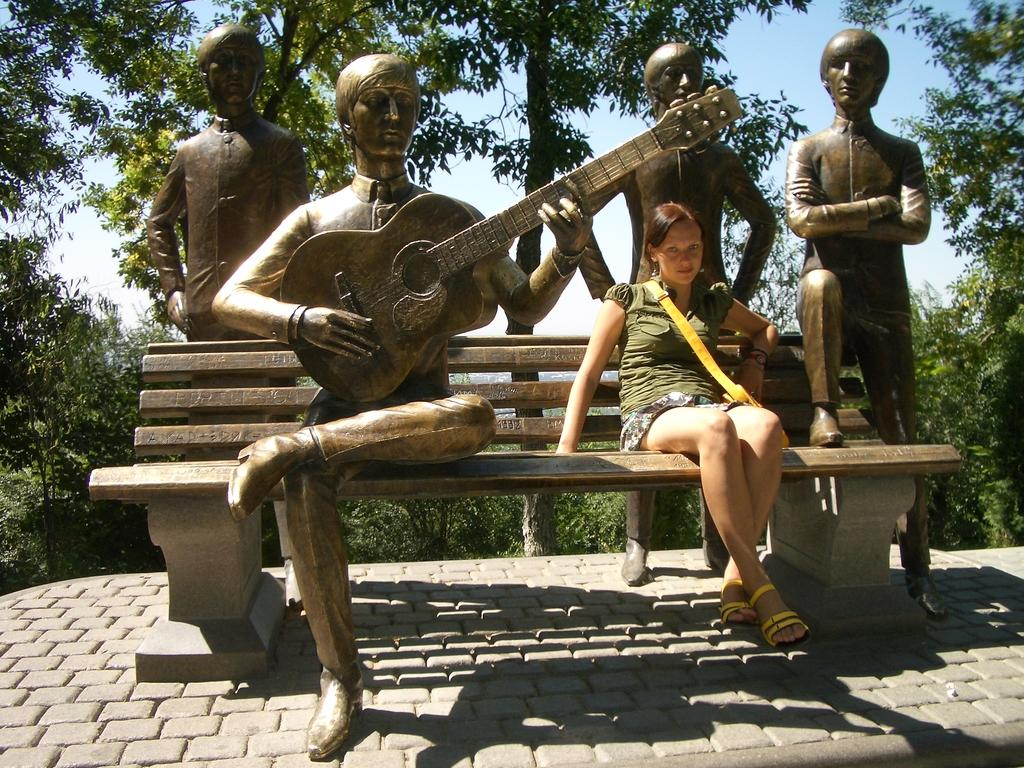What type of natural elements can be seen in the image? There are trees in the image. What is the woman in the image doing? The woman is sitting on a bench in the image. What other objects or figures are present in the image? There are sculptures in the image, including one holding a guitar. How many fans are visible in the image? There are no fans present in the image. What type of riddle can be solved by looking at the sculptures in the image? There is no riddle associated with the sculptures in the image. 